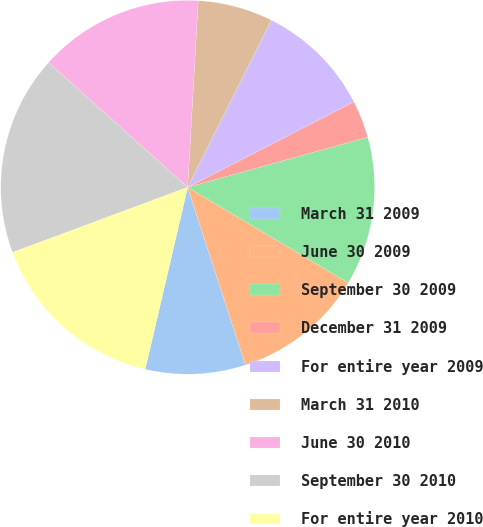Convert chart. <chart><loc_0><loc_0><loc_500><loc_500><pie_chart><fcel>March 31 2009<fcel>June 30 2009<fcel>September 30 2009<fcel>December 31 2009<fcel>For entire year 2009<fcel>March 31 2010<fcel>June 30 2010<fcel>September 30 2010<fcel>For entire year 2010<nl><fcel>8.65%<fcel>11.46%<fcel>12.86%<fcel>3.24%<fcel>10.05%<fcel>6.49%<fcel>14.27%<fcel>17.3%<fcel>15.68%<nl></chart> 